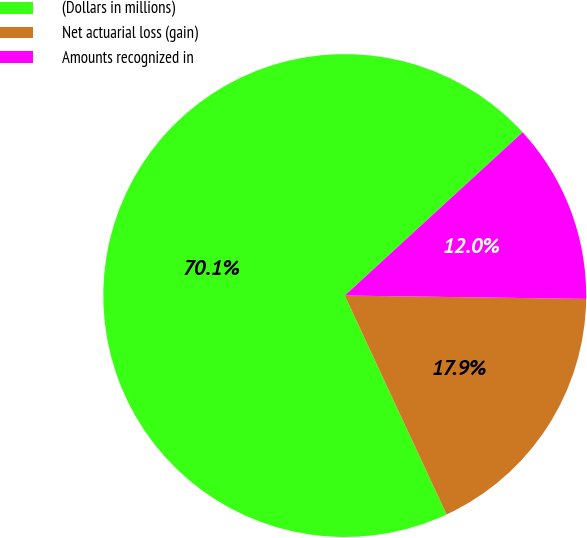Convert chart. <chart><loc_0><loc_0><loc_500><loc_500><pie_chart><fcel>(Dollars in millions)<fcel>Net actuarial loss (gain)<fcel>Amounts recognized in<nl><fcel>70.11%<fcel>17.85%<fcel>12.04%<nl></chart> 